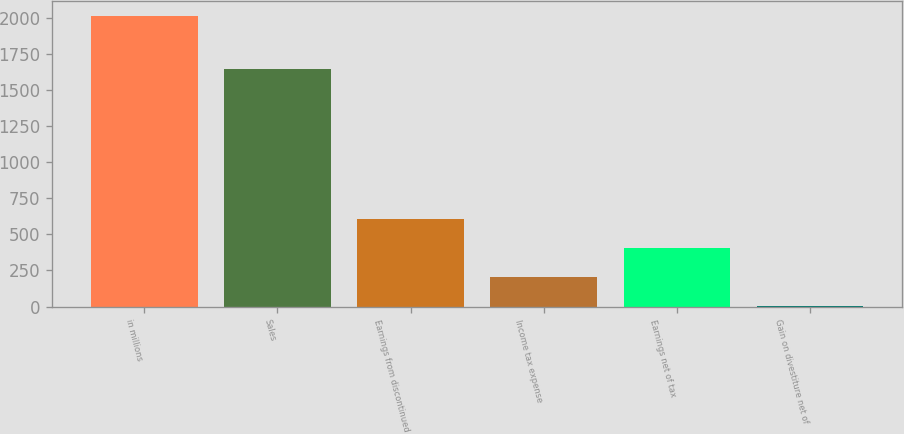Convert chart. <chart><loc_0><loc_0><loc_500><loc_500><bar_chart><fcel>in millions<fcel>Sales<fcel>Earnings from discontinued<fcel>Income tax expense<fcel>Earnings net of tax<fcel>Gain on divestiture net of<nl><fcel>2011<fcel>1646<fcel>604<fcel>202<fcel>403<fcel>1<nl></chart> 